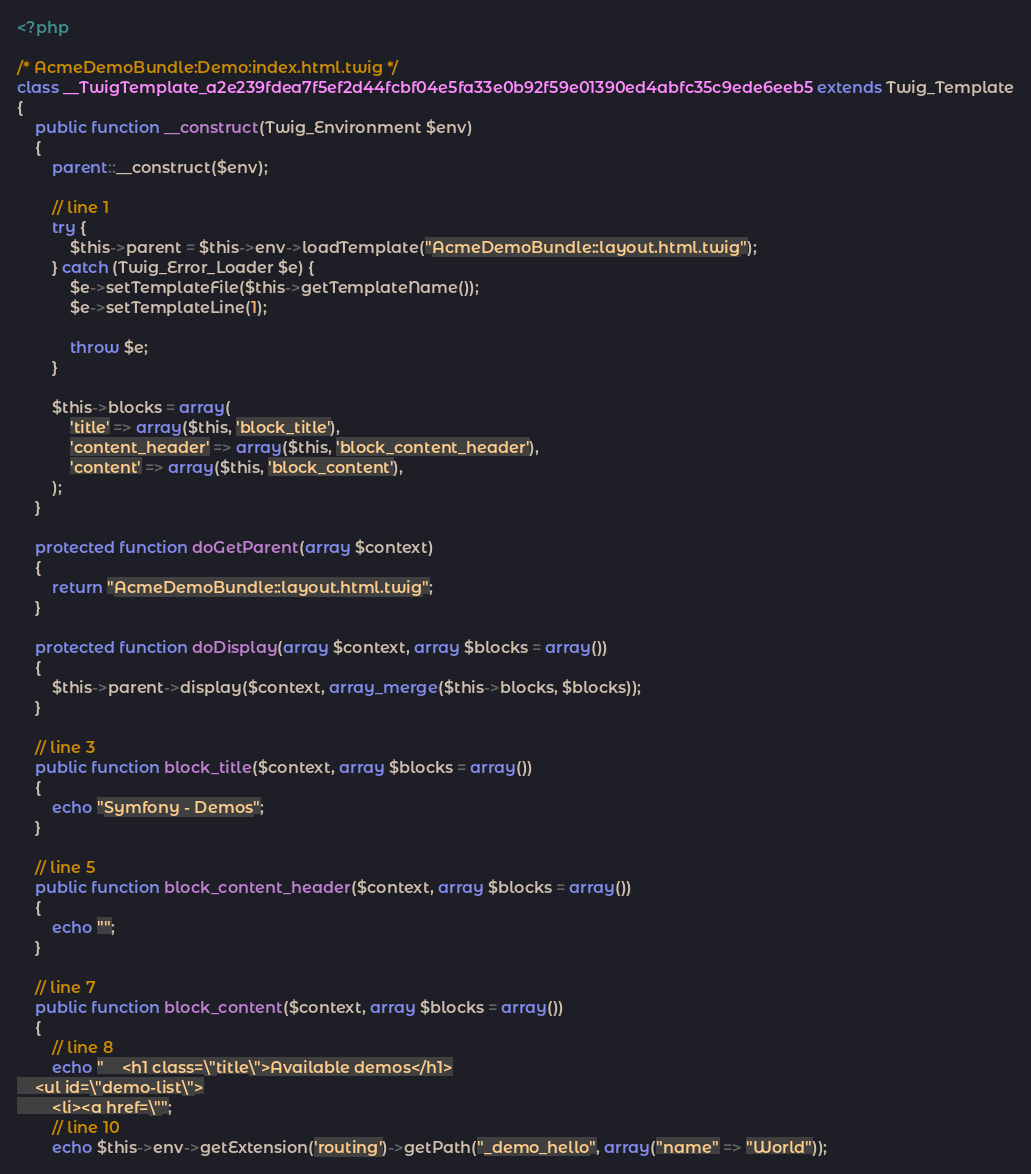<code> <loc_0><loc_0><loc_500><loc_500><_PHP_><?php

/* AcmeDemoBundle:Demo:index.html.twig */
class __TwigTemplate_a2e239fdea7f5ef2d44fcbf04e5fa33e0b92f59e01390ed4abfc35c9ede6eeb5 extends Twig_Template
{
    public function __construct(Twig_Environment $env)
    {
        parent::__construct($env);

        // line 1
        try {
            $this->parent = $this->env->loadTemplate("AcmeDemoBundle::layout.html.twig");
        } catch (Twig_Error_Loader $e) {
            $e->setTemplateFile($this->getTemplateName());
            $e->setTemplateLine(1);

            throw $e;
        }

        $this->blocks = array(
            'title' => array($this, 'block_title'),
            'content_header' => array($this, 'block_content_header'),
            'content' => array($this, 'block_content'),
        );
    }

    protected function doGetParent(array $context)
    {
        return "AcmeDemoBundle::layout.html.twig";
    }

    protected function doDisplay(array $context, array $blocks = array())
    {
        $this->parent->display($context, array_merge($this->blocks, $blocks));
    }

    // line 3
    public function block_title($context, array $blocks = array())
    {
        echo "Symfony - Demos";
    }

    // line 5
    public function block_content_header($context, array $blocks = array())
    {
        echo "";
    }

    // line 7
    public function block_content($context, array $blocks = array())
    {
        // line 8
        echo "    <h1 class=\"title\">Available demos</h1>
    <ul id=\"demo-list\">
        <li><a href=\"";
        // line 10
        echo $this->env->getExtension('routing')->getPath("_demo_hello", array("name" => "World"));</code> 